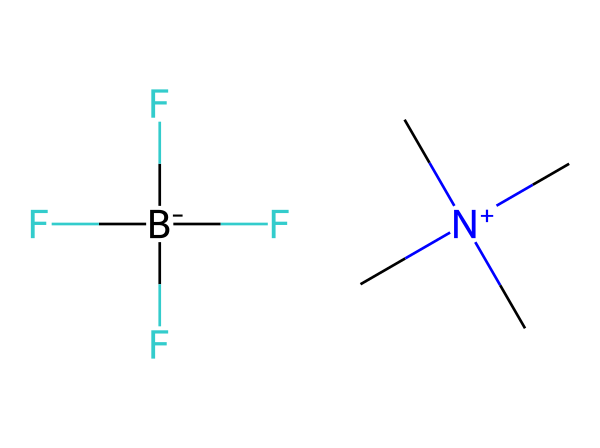What is the type of cation in this ionic liquid? The cation is a triethylammonium ion, indicated by the central nitrogen bonded to three carbon groups, which shows its positively charged nature (N+).
Answer: triethylammonium How many fluorine atoms are present in this structure? Looking at the formula, F[B-](F)(F)F indicates that there's a central boron atom bonded to four fluorine atoms (B-F bonds).
Answer: four What is the charge of the anion in this ionic liquid? The presence of the boron atom with a negative charge notation (B-) indicates that the overall charge of the anion is negative.
Answer: negative What type of interaction do ionic liquids exhibit due to their ionic nature? The ionic nature of the liquid leads to strong ion-dipole and ionic interactions, which are significant for their solvating properties.
Answer: ionic interactions What is the main application of the ionic liquid in this context? The structure is designed for organic synthesis in pharmaceutical development, indicating its application in chemical reactions likely involving solvation and reactivity.
Answer: organic synthesis 